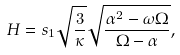<formula> <loc_0><loc_0><loc_500><loc_500>H = s _ { 1 } \sqrt { \frac { 3 } { \kappa } } \sqrt { \frac { \alpha ^ { 2 } - \omega \Omega } { \Omega - \alpha } } ,</formula> 